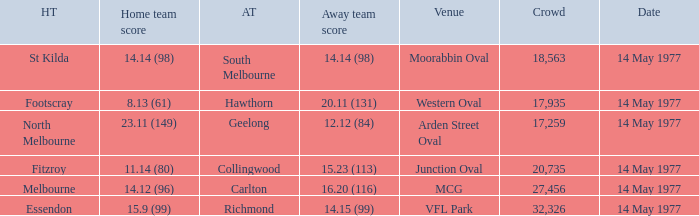How many people were in the crowd with the away team being collingwood? 1.0. 